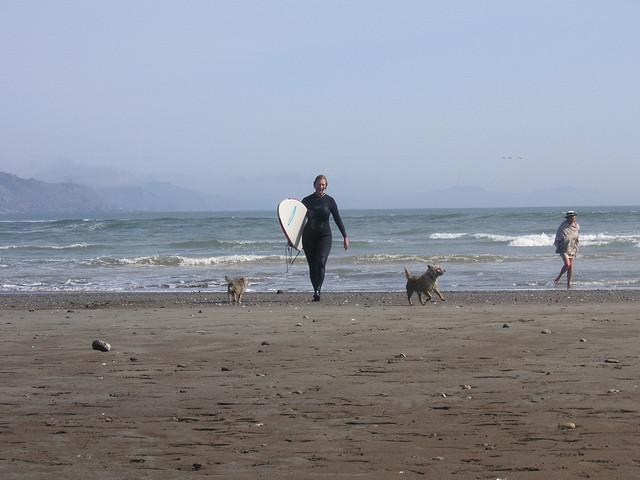How many dogs are on the beach?
Give a very brief answer. 2. How many people are in the photo?
Give a very brief answer. 2. How many people can be seen?
Give a very brief answer. 1. 